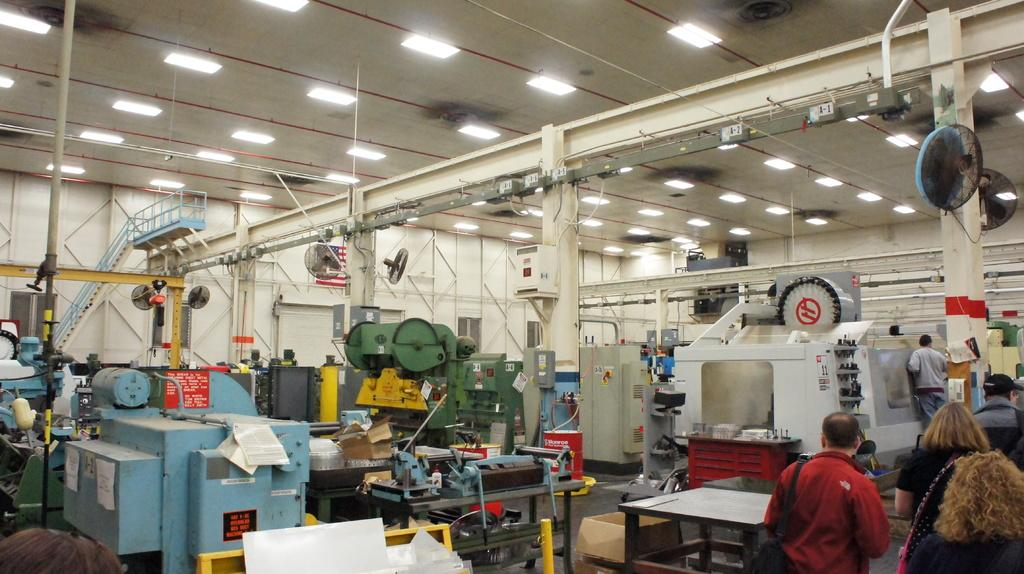What is the color of the wall in the image? The wall in the image is white. What can be seen hanging from the ceiling in the image? There are fans in the image. What architectural feature is present in the image? There are stairs in the image. What type of equipment is visible in the image? There is electrical equipment in the image. Who or what is present in the image? There are people present in the image. What territory is being claimed by the writer in the image? There is no writer or territory mentioned in the image; it features a white wall, fans, stairs, electrical equipment, and people. 